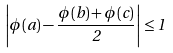<formula> <loc_0><loc_0><loc_500><loc_500>\left | \phi ( a ) - \frac { \phi ( b ) + \phi ( c ) } { 2 } \right | \leq 1</formula> 